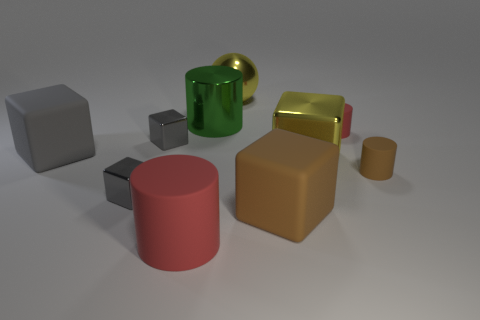How many gray cubes must be subtracted to get 1 gray cubes? 2 Subtract all green cylinders. How many gray cubes are left? 3 Subtract 2 cubes. How many cubes are left? 3 Subtract all gray rubber cubes. How many cubes are left? 4 Subtract all brown blocks. How many blocks are left? 4 Subtract all gray cylinders. Subtract all green cubes. How many cylinders are left? 4 Subtract all spheres. How many objects are left? 9 Subtract 1 red cylinders. How many objects are left? 9 Subtract all small matte objects. Subtract all big gray cubes. How many objects are left? 7 Add 8 brown objects. How many brown objects are left? 10 